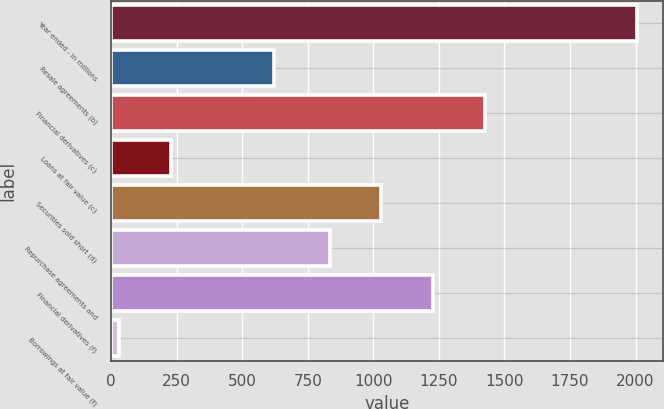Convert chart. <chart><loc_0><loc_0><loc_500><loc_500><bar_chart><fcel>Year ended - in millions<fcel>Resale agreements (b)<fcel>Financial derivatives (c)<fcel>Loans at fair value (c)<fcel>Securities sold short (d)<fcel>Repurchase agreements and<fcel>Financial derivatives (f)<fcel>Borrowings at fair value (f)<nl><fcel>2006<fcel>623<fcel>1425.5<fcel>228.5<fcel>1030.5<fcel>833<fcel>1228<fcel>31<nl></chart> 